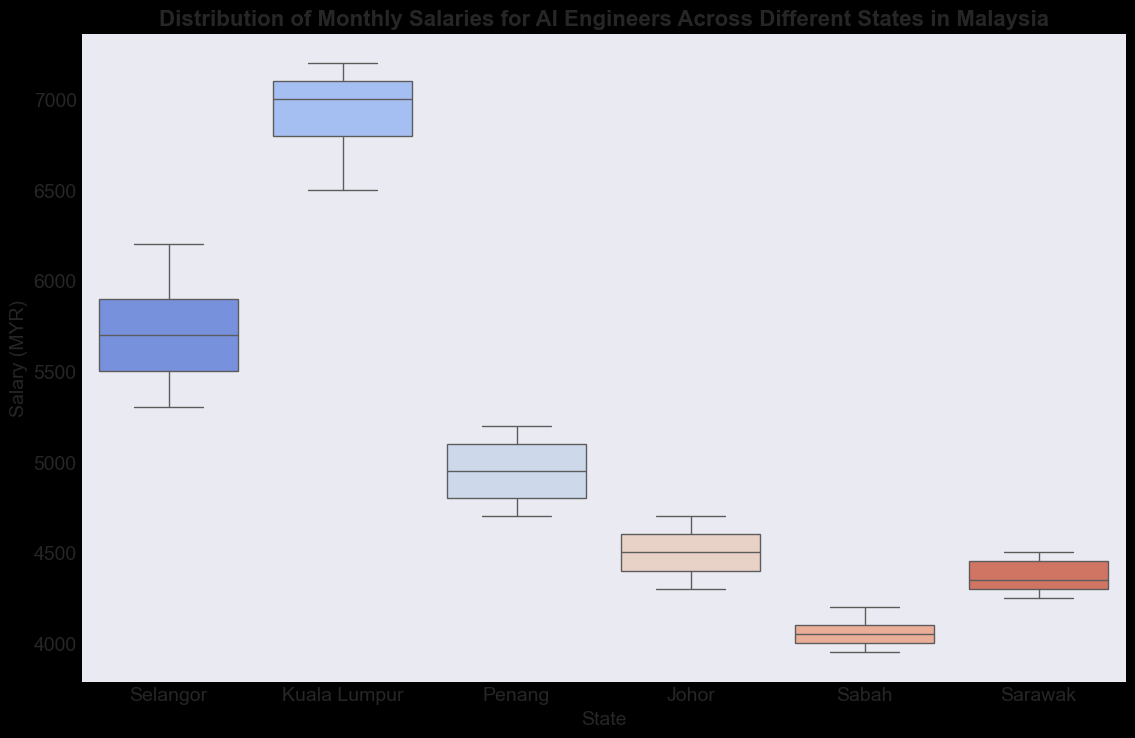What is the median salary for AI engineers in Kuala Lumpur? To find the median salary, identify the middle value when the data points are arranged in ascending order. For Kuala Lumpur, the salaries are: 6500, 6800, 7000, 7100, 7200. The median is the third value, which is 7000.
Answer: 7000 Which state has the highest median salary for AI engineers? Compare the median salaries of all states. From the box plot, it is visible that Kuala Lumpur has the highest median salary compared to other states.
Answer: Kuala Lumpur What is the interquartile range (IQR) of salaries for Selangor? The IQR is found by subtracting the first quartile (Q1) from the third quartile (Q3). Based on the box plot for Selangor, approximate Q1 and Q3 and subtract Q1 from Q3. For Selangor, Q1 ≈ 5500 and Q3 ≈ 6100, so IQR = 6100 - 5500 = 600.
Answer: 600 Compare the median salaries in Penang and Johor. Which state has the higher median salary? The box plot shows both the medians for Penang and Johor. Penang's median is higher than Johor's.
Answer: Penang Is there a state where the salaries have no outliers? Look for states with whiskers extending to the furthest points without any separate points beyond the whiskers. For instance, Johor has no obvious outliers in its salary distribution.
Answer: Johor How does the salary distribution in Sabah compare with Sarawak? Examine the box plot representations for both states. Sabah has a lower median salary and a narrower range of salary distribution compared to Sarawak. Also, Sarawak has a higher maximum salary.
Answer: Sabah has a lower median and narrower range Which state has the widest range of salaries for AI engineers? The range is determined by the distance between the minimum and maximum values represented by the whiskers of the box plot. Selangor has the widest range of salaries as the whiskers extend the furthest apart.
Answer: Selangor Identify the state with the smallest interquartile range (IQR) for salaries. The IQR is the range between Q1 and Q3 (the width of the box). By comparing the widths of the boxes in the box plot, Johor has the smallest IQR.
Answer: Johor Are there any states with symmetric salary distributions, and if so, which ones? Symmetric distributions have medians approximately in the middle of the boxes and equal whisker lengths. Based on the box plot, Selangor’s distribution seems fairly symmetric.
Answer: Selangor Which state has the overall lowest individual salary for AI engineers, and what is that salary? By identifying the lowest point in the box plot whiskers, the lowest individual salary is in Sabah, which is approximately 3950.
Answer: Sabah, 3950 